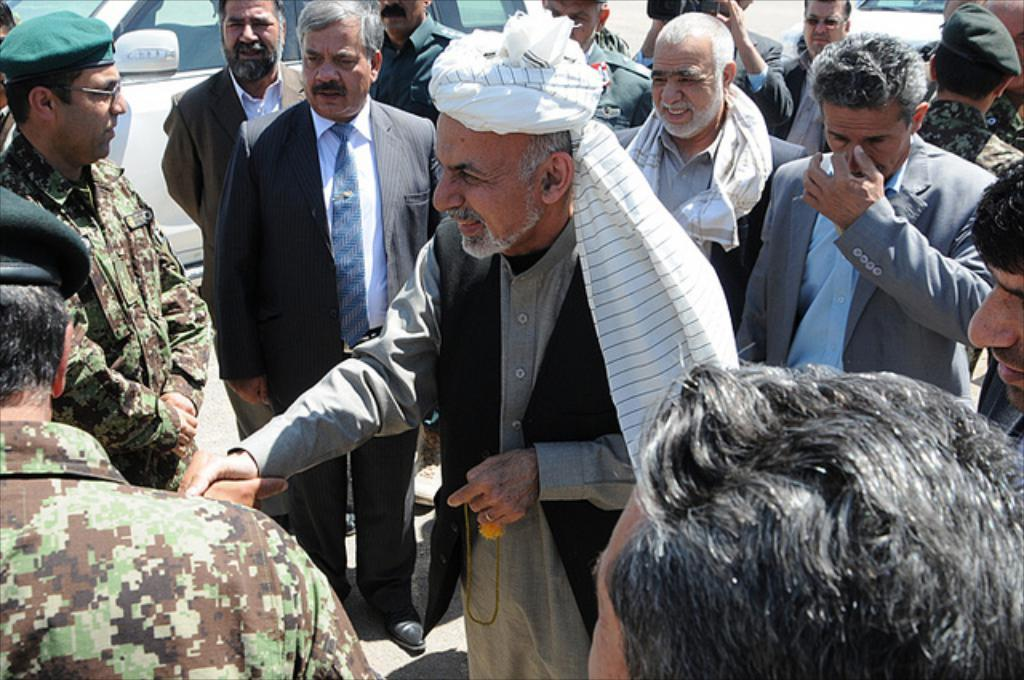What is the main subject of the image? The main subject of the image is a crowd of people. Can you describe any other objects or elements in the image? Yes, there is a vehicle in the image. How many tickets are visible in the image? There is no mention of tickets in the image, so it is not possible to determine how many are visible. 